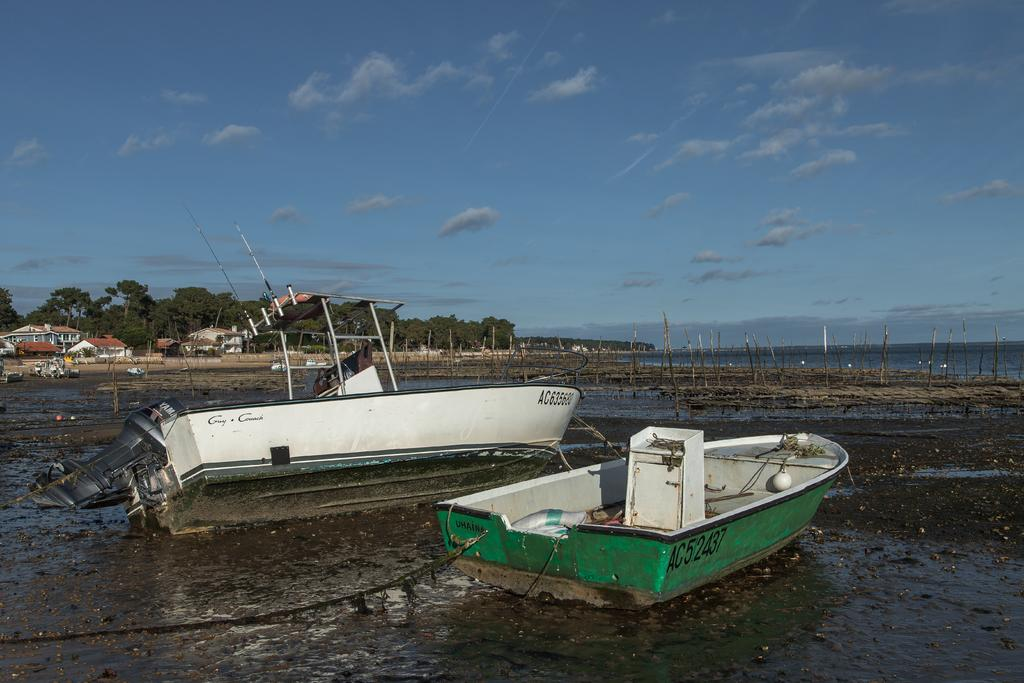What type of vehicles can be seen in the image? There are boats in the image. What structures are visible in the background of the image? There are buildings in the background of the image. What type of vegetation is present in the background of the image? There are trees in the background of the image. What is visible in the background of the image? The sky is visible in the background of the image. What type of fight is taking place between the boats in the image? There is no fight taking place between the boats in the image; they are simply visible in the water. What type of scale is being used to weigh the flesh of the animals in the image? There is no scale or flesh of animals present in the image. 